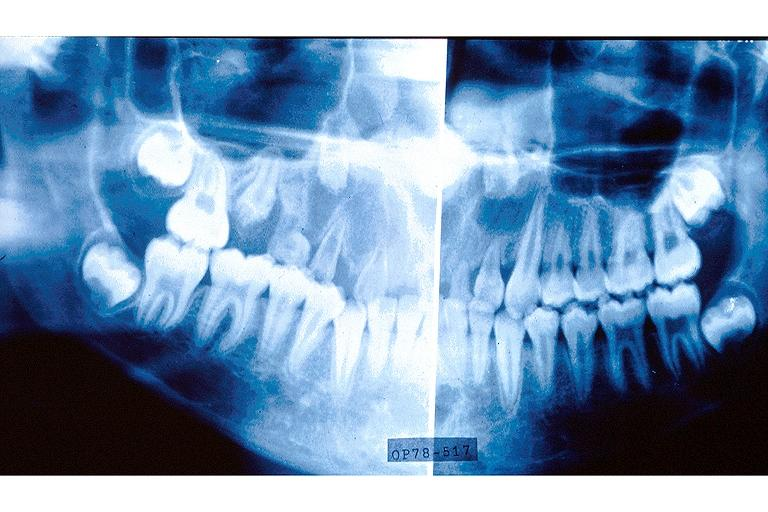s oral present?
Answer the question using a single word or phrase. Yes 